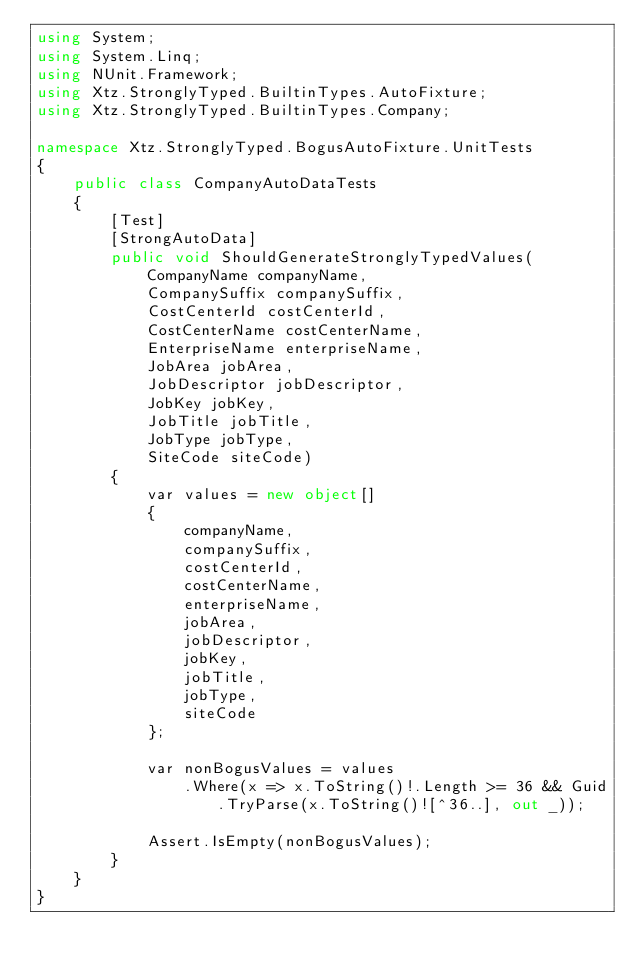Convert code to text. <code><loc_0><loc_0><loc_500><loc_500><_C#_>using System;
using System.Linq;
using NUnit.Framework;
using Xtz.StronglyTyped.BuiltinTypes.AutoFixture;
using Xtz.StronglyTyped.BuiltinTypes.Company;

namespace Xtz.StronglyTyped.BogusAutoFixture.UnitTests
{
    public class CompanyAutoDataTests
    {
        [Test]
        [StrongAutoData]
        public void ShouldGenerateStronglyTypedValues(
            CompanyName companyName,
            CompanySuffix companySuffix,
            CostCenterId costCenterId,
            CostCenterName costCenterName,
            EnterpriseName enterpriseName,
            JobArea jobArea,
            JobDescriptor jobDescriptor,
            JobKey jobKey,
            JobTitle jobTitle,
            JobType jobType,
            SiteCode siteCode)
        {
            var values = new object[]
            {
                companyName,
                companySuffix,
                costCenterId,
                costCenterName,
                enterpriseName,
                jobArea,
                jobDescriptor,
                jobKey,
                jobTitle,
                jobType,
                siteCode
            };

            var nonBogusValues = values
                .Where(x => x.ToString()!.Length >= 36 && Guid.TryParse(x.ToString()![^36..], out _));

            Assert.IsEmpty(nonBogusValues);
        }
    }
}</code> 